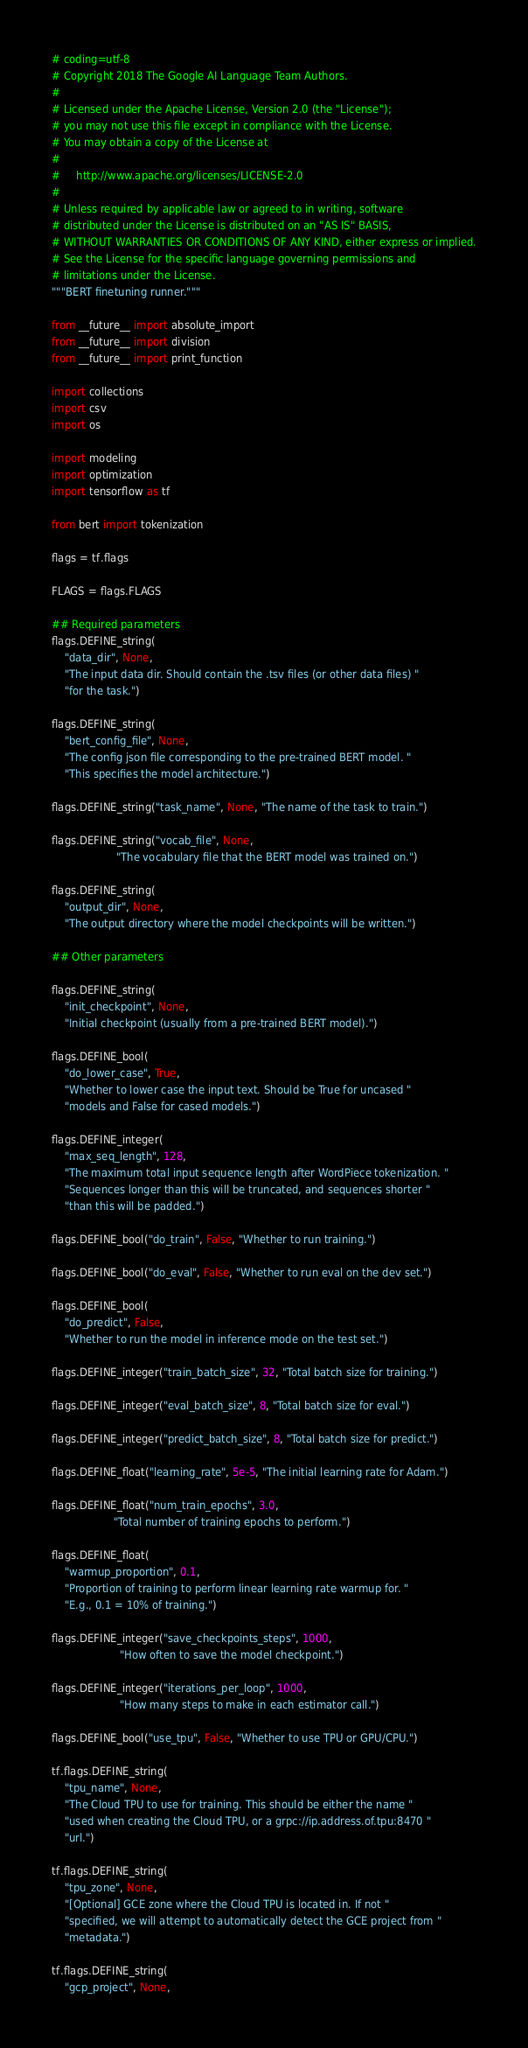<code> <loc_0><loc_0><loc_500><loc_500><_Python_># coding=utf-8
# Copyright 2018 The Google AI Language Team Authors.
#
# Licensed under the Apache License, Version 2.0 (the "License");
# you may not use this file except in compliance with the License.
# You may obtain a copy of the License at
#
#     http://www.apache.org/licenses/LICENSE-2.0
#
# Unless required by applicable law or agreed to in writing, software
# distributed under the License is distributed on an "AS IS" BASIS,
# WITHOUT WARRANTIES OR CONDITIONS OF ANY KIND, either express or implied.
# See the License for the specific language governing permissions and
# limitations under the License.
"""BERT finetuning runner."""

from __future__ import absolute_import
from __future__ import division
from __future__ import print_function

import collections
import csv
import os

import modeling
import optimization
import tensorflow as tf

from bert import tokenization

flags = tf.flags

FLAGS = flags.FLAGS

## Required parameters
flags.DEFINE_string(
    "data_dir", None,
    "The input data dir. Should contain the .tsv files (or other data files) "
    "for the task.")

flags.DEFINE_string(
    "bert_config_file", None,
    "The config json file corresponding to the pre-trained BERT model. "
    "This specifies the model architecture.")

flags.DEFINE_string("task_name", None, "The name of the task to train.")

flags.DEFINE_string("vocab_file", None,
                    "The vocabulary file that the BERT model was trained on.")

flags.DEFINE_string(
    "output_dir", None,
    "The output directory where the model checkpoints will be written.")

## Other parameters

flags.DEFINE_string(
    "init_checkpoint", None,
    "Initial checkpoint (usually from a pre-trained BERT model).")

flags.DEFINE_bool(
    "do_lower_case", True,
    "Whether to lower case the input text. Should be True for uncased "
    "models and False for cased models.")

flags.DEFINE_integer(
    "max_seq_length", 128,
    "The maximum total input sequence length after WordPiece tokenization. "
    "Sequences longer than this will be truncated, and sequences shorter "
    "than this will be padded.")

flags.DEFINE_bool("do_train", False, "Whether to run training.")

flags.DEFINE_bool("do_eval", False, "Whether to run eval on the dev set.")

flags.DEFINE_bool(
    "do_predict", False,
    "Whether to run the model in inference mode on the test set.")

flags.DEFINE_integer("train_batch_size", 32, "Total batch size for training.")

flags.DEFINE_integer("eval_batch_size", 8, "Total batch size for eval.")

flags.DEFINE_integer("predict_batch_size", 8, "Total batch size for predict.")

flags.DEFINE_float("learning_rate", 5e-5, "The initial learning rate for Adam.")

flags.DEFINE_float("num_train_epochs", 3.0,
                   "Total number of training epochs to perform.")

flags.DEFINE_float(
    "warmup_proportion", 0.1,
    "Proportion of training to perform linear learning rate warmup for. "
    "E.g., 0.1 = 10% of training.")

flags.DEFINE_integer("save_checkpoints_steps", 1000,
                     "How often to save the model checkpoint.")

flags.DEFINE_integer("iterations_per_loop", 1000,
                     "How many steps to make in each estimator call.")

flags.DEFINE_bool("use_tpu", False, "Whether to use TPU or GPU/CPU.")

tf.flags.DEFINE_string(
    "tpu_name", None,
    "The Cloud TPU to use for training. This should be either the name "
    "used when creating the Cloud TPU, or a grpc://ip.address.of.tpu:8470 "
    "url.")

tf.flags.DEFINE_string(
    "tpu_zone", None,
    "[Optional] GCE zone where the Cloud TPU is located in. If not "
    "specified, we will attempt to automatically detect the GCE project from "
    "metadata.")

tf.flags.DEFINE_string(
    "gcp_project", None,</code> 